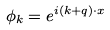<formula> <loc_0><loc_0><loc_500><loc_500>\phi _ { k } = e ^ { i ( { k } + { q } ) \cdot { x } }</formula> 